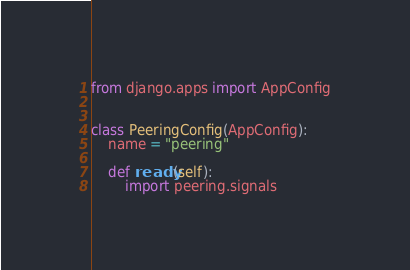Convert code to text. <code><loc_0><loc_0><loc_500><loc_500><_Python_>from django.apps import AppConfig


class PeeringConfig(AppConfig):
    name = "peering"

    def ready(self):
        import peering.signals
</code> 